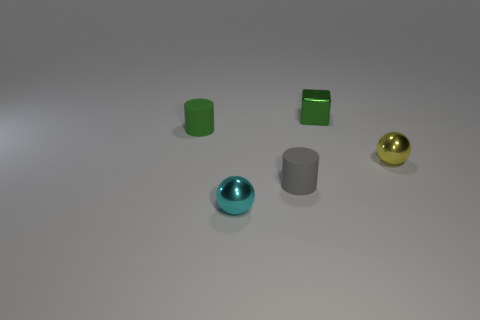There is a object that is the same color as the cube; what is its size?
Make the answer very short. Small. How many blue things are either small blocks or tiny spheres?
Offer a very short reply. 0. Is there a matte thing of the same color as the metallic cube?
Ensure brevity in your answer.  Yes. What is the size of the cyan sphere that is made of the same material as the green block?
Ensure brevity in your answer.  Small. What number of blocks are either gray objects or shiny things?
Make the answer very short. 1. Is the number of small green matte cylinders greater than the number of tiny blue spheres?
Provide a succinct answer. Yes. What number of gray cylinders are the same size as the yellow shiny thing?
Keep it short and to the point. 1. The thing that is the same color as the small block is what shape?
Keep it short and to the point. Cylinder. What number of objects are small cylinders to the left of the small yellow shiny object or small rubber cylinders?
Offer a very short reply. 2. Is the number of tiny cyan balls less than the number of metal things?
Provide a short and direct response. Yes. 